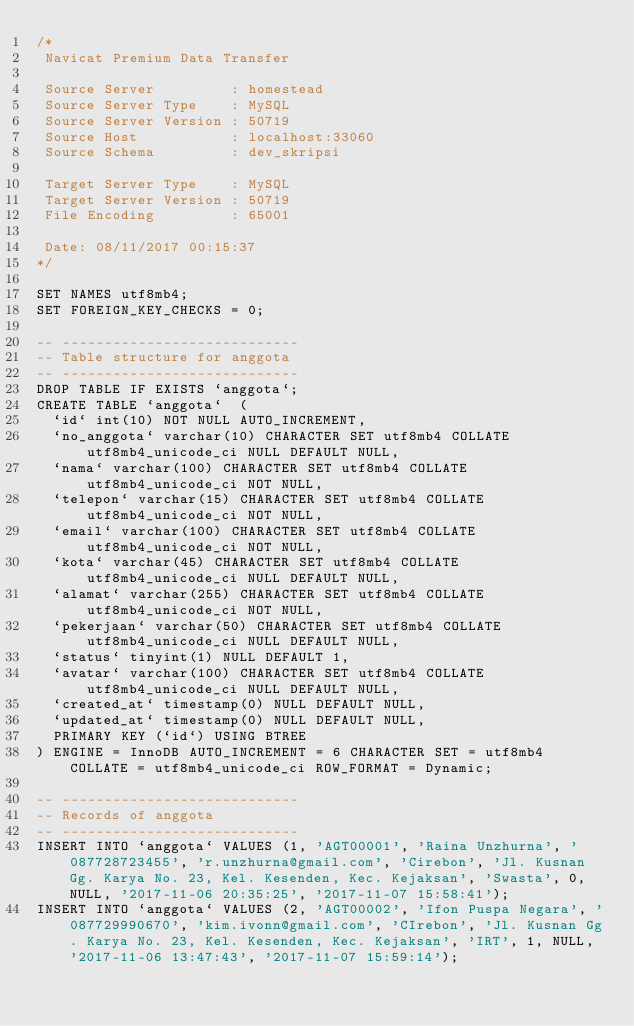<code> <loc_0><loc_0><loc_500><loc_500><_SQL_>/*
 Navicat Premium Data Transfer

 Source Server         : homestead
 Source Server Type    : MySQL
 Source Server Version : 50719
 Source Host           : localhost:33060
 Source Schema         : dev_skripsi

 Target Server Type    : MySQL
 Target Server Version : 50719
 File Encoding         : 65001

 Date: 08/11/2017 00:15:37
*/

SET NAMES utf8mb4;
SET FOREIGN_KEY_CHECKS = 0;

-- ----------------------------
-- Table structure for anggota
-- ----------------------------
DROP TABLE IF EXISTS `anggota`;
CREATE TABLE `anggota`  (
  `id` int(10) NOT NULL AUTO_INCREMENT,
  `no_anggota` varchar(10) CHARACTER SET utf8mb4 COLLATE utf8mb4_unicode_ci NULL DEFAULT NULL,
  `nama` varchar(100) CHARACTER SET utf8mb4 COLLATE utf8mb4_unicode_ci NOT NULL,
  `telepon` varchar(15) CHARACTER SET utf8mb4 COLLATE utf8mb4_unicode_ci NOT NULL,
  `email` varchar(100) CHARACTER SET utf8mb4 COLLATE utf8mb4_unicode_ci NOT NULL,
  `kota` varchar(45) CHARACTER SET utf8mb4 COLLATE utf8mb4_unicode_ci NULL DEFAULT NULL,
  `alamat` varchar(255) CHARACTER SET utf8mb4 COLLATE utf8mb4_unicode_ci NOT NULL,
  `pekerjaan` varchar(50) CHARACTER SET utf8mb4 COLLATE utf8mb4_unicode_ci NULL DEFAULT NULL,
  `status` tinyint(1) NULL DEFAULT 1,
  `avatar` varchar(100) CHARACTER SET utf8mb4 COLLATE utf8mb4_unicode_ci NULL DEFAULT NULL,
  `created_at` timestamp(0) NULL DEFAULT NULL,
  `updated_at` timestamp(0) NULL DEFAULT NULL,
  PRIMARY KEY (`id`) USING BTREE
) ENGINE = InnoDB AUTO_INCREMENT = 6 CHARACTER SET = utf8mb4 COLLATE = utf8mb4_unicode_ci ROW_FORMAT = Dynamic;

-- ----------------------------
-- Records of anggota
-- ----------------------------
INSERT INTO `anggota` VALUES (1, 'AGT00001', 'Raina Unzhurna', '087728723455', 'r.unzhurna@gmail.com', 'Cirebon', 'Jl. Kusnan Gg. Karya No. 23, Kel. Kesenden, Kec. Kejaksan', 'Swasta', 0, NULL, '2017-11-06 20:35:25', '2017-11-07 15:58:41');
INSERT INTO `anggota` VALUES (2, 'AGT00002', 'Ifon Puspa Negara', '087729990670', 'kim.ivonn@gmail.com', 'CIrebon', 'Jl. Kusnan Gg. Karya No. 23, Kel. Kesenden, Kec. Kejaksan', 'IRT', 1, NULL, '2017-11-06 13:47:43', '2017-11-07 15:59:14');</code> 